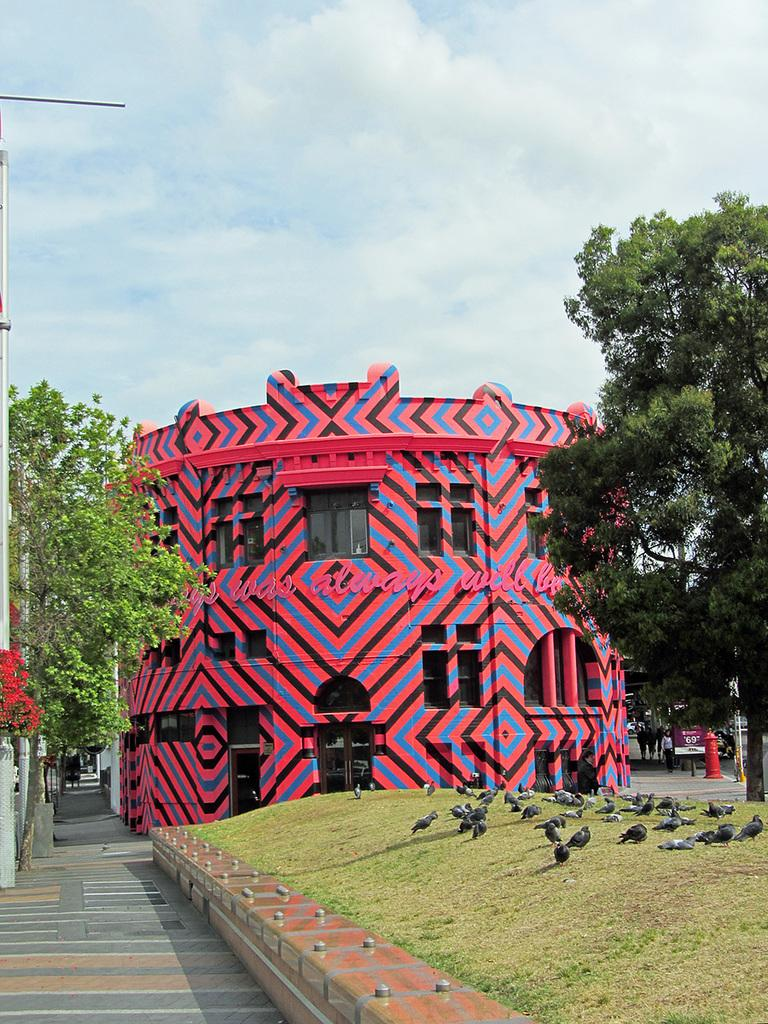What color is the building in the image? The building in the image is pink. What type of surface is in front of the building? There is a grass surface in front of the building. What can be seen on the grass surface? There are many birds on the grass surface. What type of vegetation surrounds the building? There are trees around the building. What type of neck accessory is visible on the birds in the image? There are no neck accessories visible on the birds in the image. What type of alley can be seen behind the building in the image? There is no alley visible behind the building in the image. 